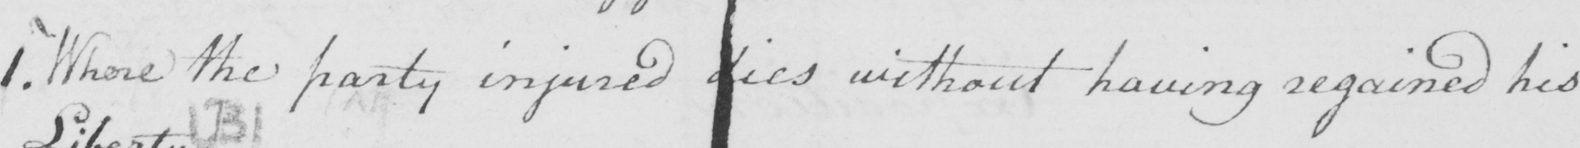What text is written in this handwritten line? 1 . Where the party injured dies without having regained his 